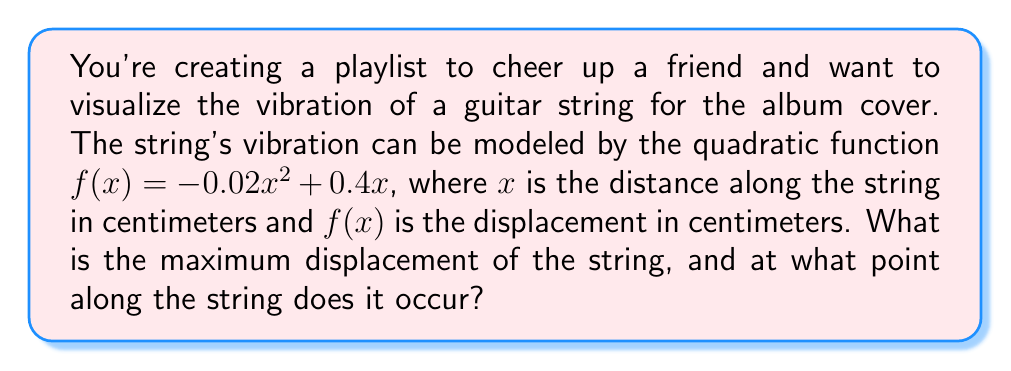Can you solve this math problem? To find the maximum displacement and its location, we need to follow these steps:

1) The quadratic function is in the form $f(x) = ax^2 + bx + c$, where $a = -0.02$, $b = 0.4$, and $c = 0$.

2) For a quadratic function, the x-coordinate of the vertex represents the point where the maximum (or minimum) occurs. We can find this using the formula: $x = -\frac{b}{2a}$

3) Substituting our values:
   $x = -\frac{0.4}{2(-0.02)} = -\frac{0.4}{-0.04} = 10$

4) To find the maximum displacement, we need to calculate $f(10)$:
   $f(10) = -0.02(10)^2 + 0.4(10)$
   $= -0.02(100) + 4$
   $= -2 + 4 = 2$

5) Therefore, the maximum displacement occurs at $x = 10$ cm along the string, and the displacement at this point is 2 cm.
Answer: Maximum displacement: 2 cm at $x = 10$ cm 